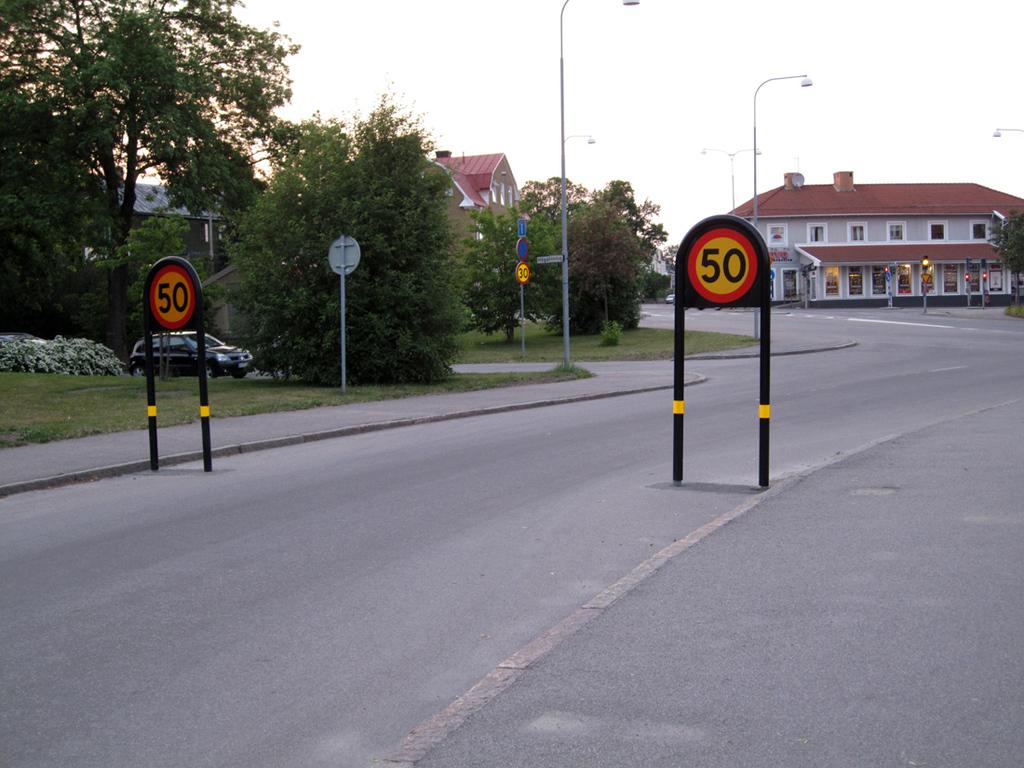Do both signs have the same number?
Your answer should be very brief. Yes. What is the speed limit here?
Keep it short and to the point. 50. 